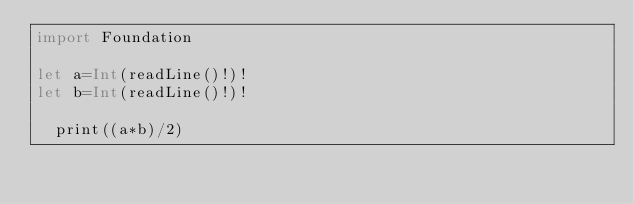<code> <loc_0><loc_0><loc_500><loc_500><_Swift_>import Foundation
 
let a=Int(readLine()!)!
let b=Int(readLine()!)!
 
  print((a*b)/2)
</code> 